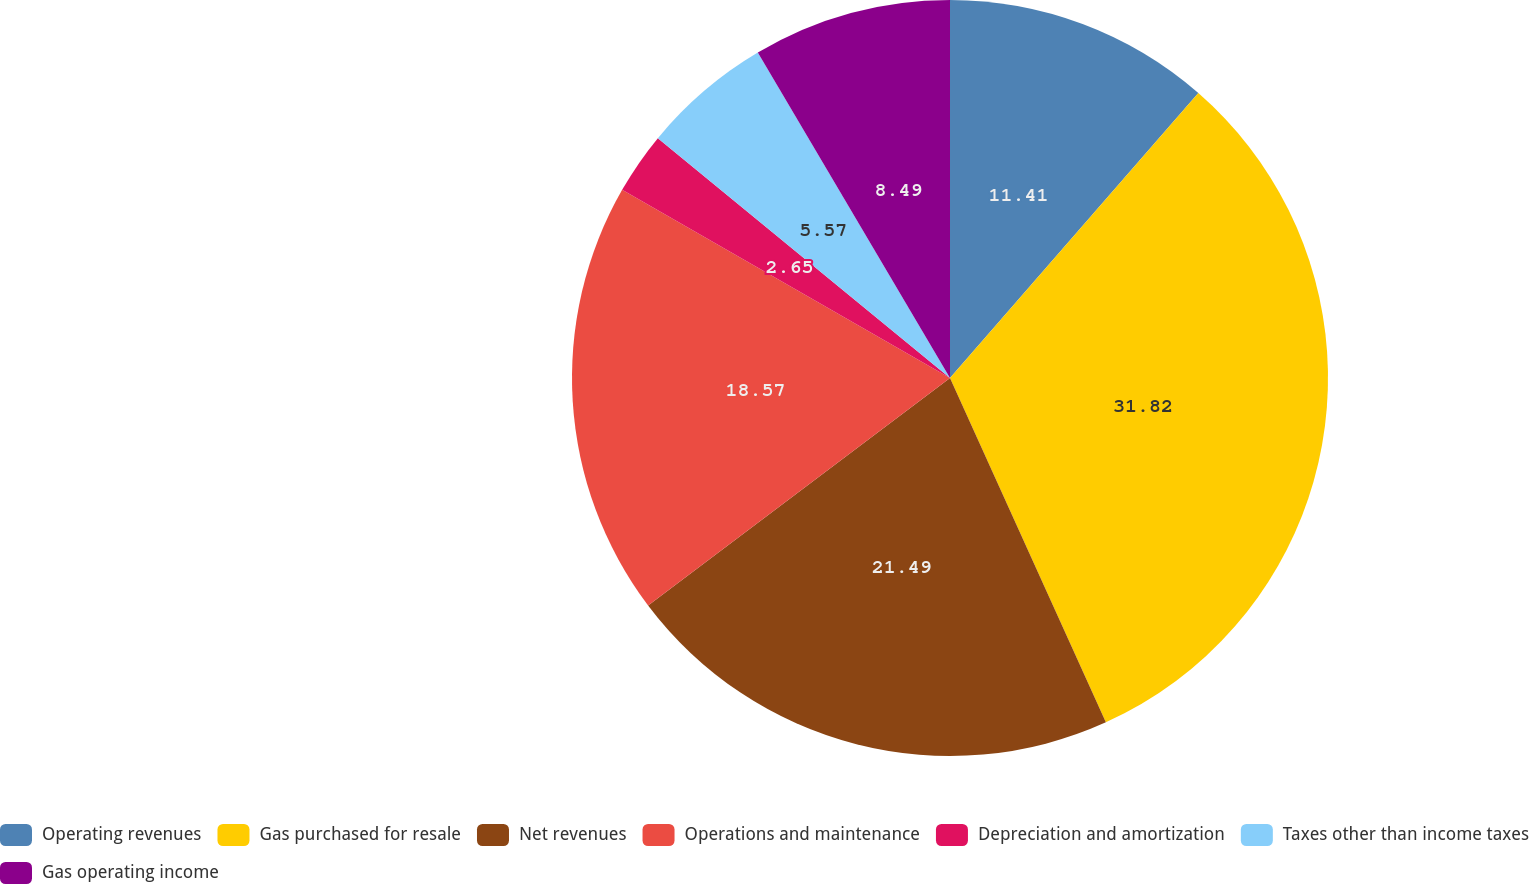Convert chart. <chart><loc_0><loc_0><loc_500><loc_500><pie_chart><fcel>Operating revenues<fcel>Gas purchased for resale<fcel>Net revenues<fcel>Operations and maintenance<fcel>Depreciation and amortization<fcel>Taxes other than income taxes<fcel>Gas operating income<nl><fcel>11.41%<fcel>31.83%<fcel>21.49%<fcel>18.57%<fcel>2.65%<fcel>5.57%<fcel>8.49%<nl></chart> 